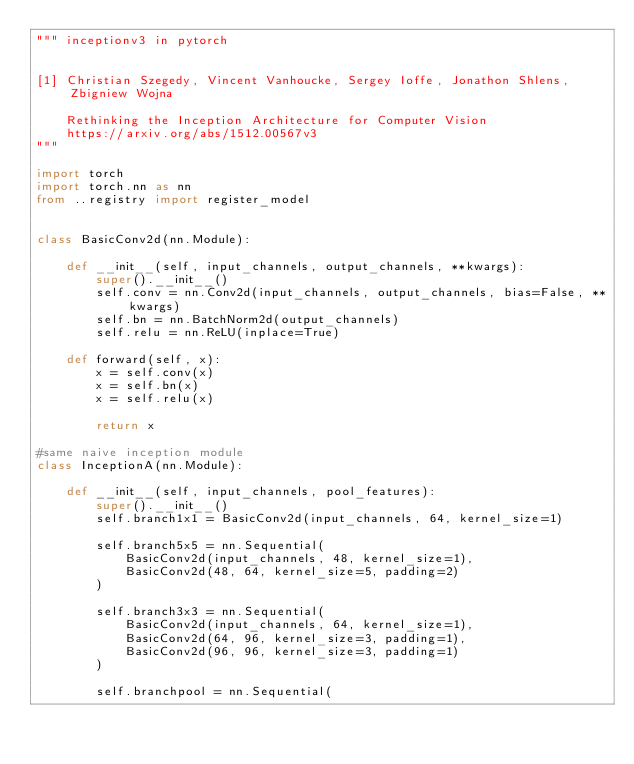Convert code to text. <code><loc_0><loc_0><loc_500><loc_500><_Python_>""" inceptionv3 in pytorch


[1] Christian Szegedy, Vincent Vanhoucke, Sergey Ioffe, Jonathon Shlens, Zbigniew Wojna

    Rethinking the Inception Architecture for Computer Vision
    https://arxiv.org/abs/1512.00567v3
"""

import torch
import torch.nn as nn
from ..registry import register_model


class BasicConv2d(nn.Module):

    def __init__(self, input_channels, output_channels, **kwargs):
        super().__init__()
        self.conv = nn.Conv2d(input_channels, output_channels, bias=False, **kwargs)
        self.bn = nn.BatchNorm2d(output_channels)
        self.relu = nn.ReLU(inplace=True)

    def forward(self, x):
        x = self.conv(x)
        x = self.bn(x)
        x = self.relu(x)

        return x

#same naive inception module
class InceptionA(nn.Module):

    def __init__(self, input_channels, pool_features):
        super().__init__()
        self.branch1x1 = BasicConv2d(input_channels, 64, kernel_size=1)

        self.branch5x5 = nn.Sequential(
            BasicConv2d(input_channels, 48, kernel_size=1),
            BasicConv2d(48, 64, kernel_size=5, padding=2)
        )

        self.branch3x3 = nn.Sequential(
            BasicConv2d(input_channels, 64, kernel_size=1),
            BasicConv2d(64, 96, kernel_size=3, padding=1),
            BasicConv2d(96, 96, kernel_size=3, padding=1)
        )

        self.branchpool = nn.Sequential(</code> 